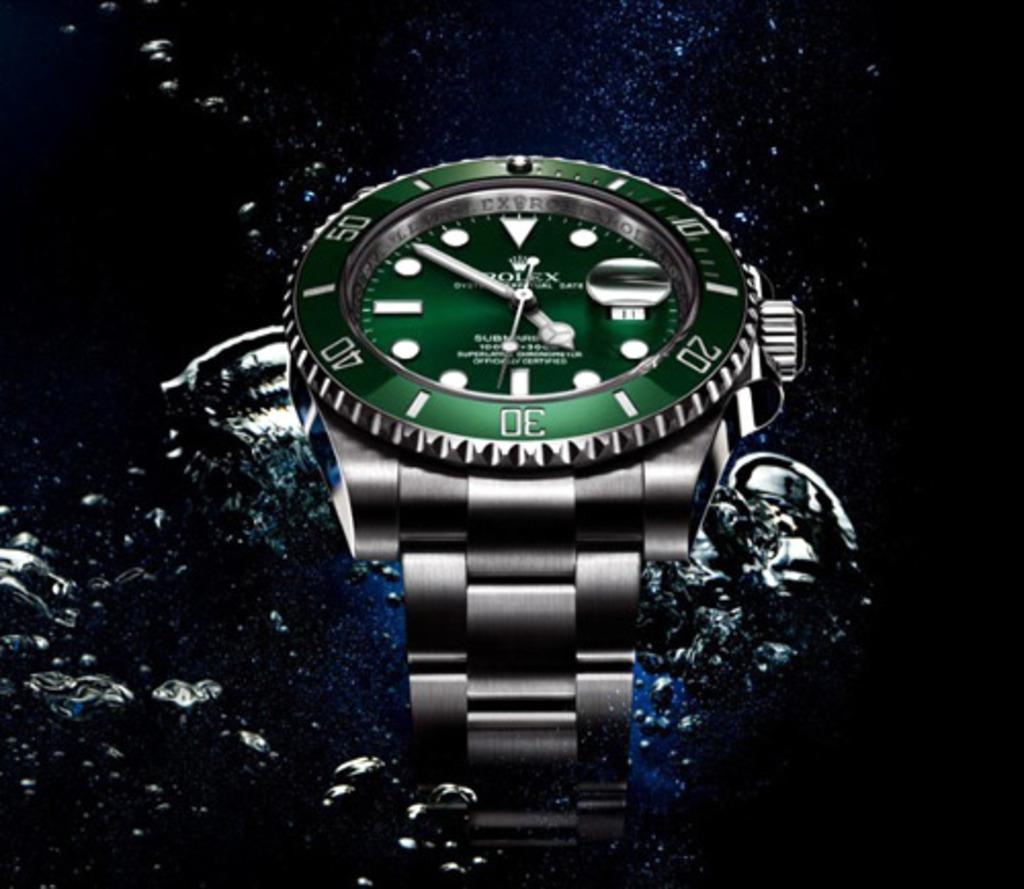What brand of watch is advertised?
Give a very brief answer. Rolex. Is that an original rolex?
Ensure brevity in your answer.  Yes. 